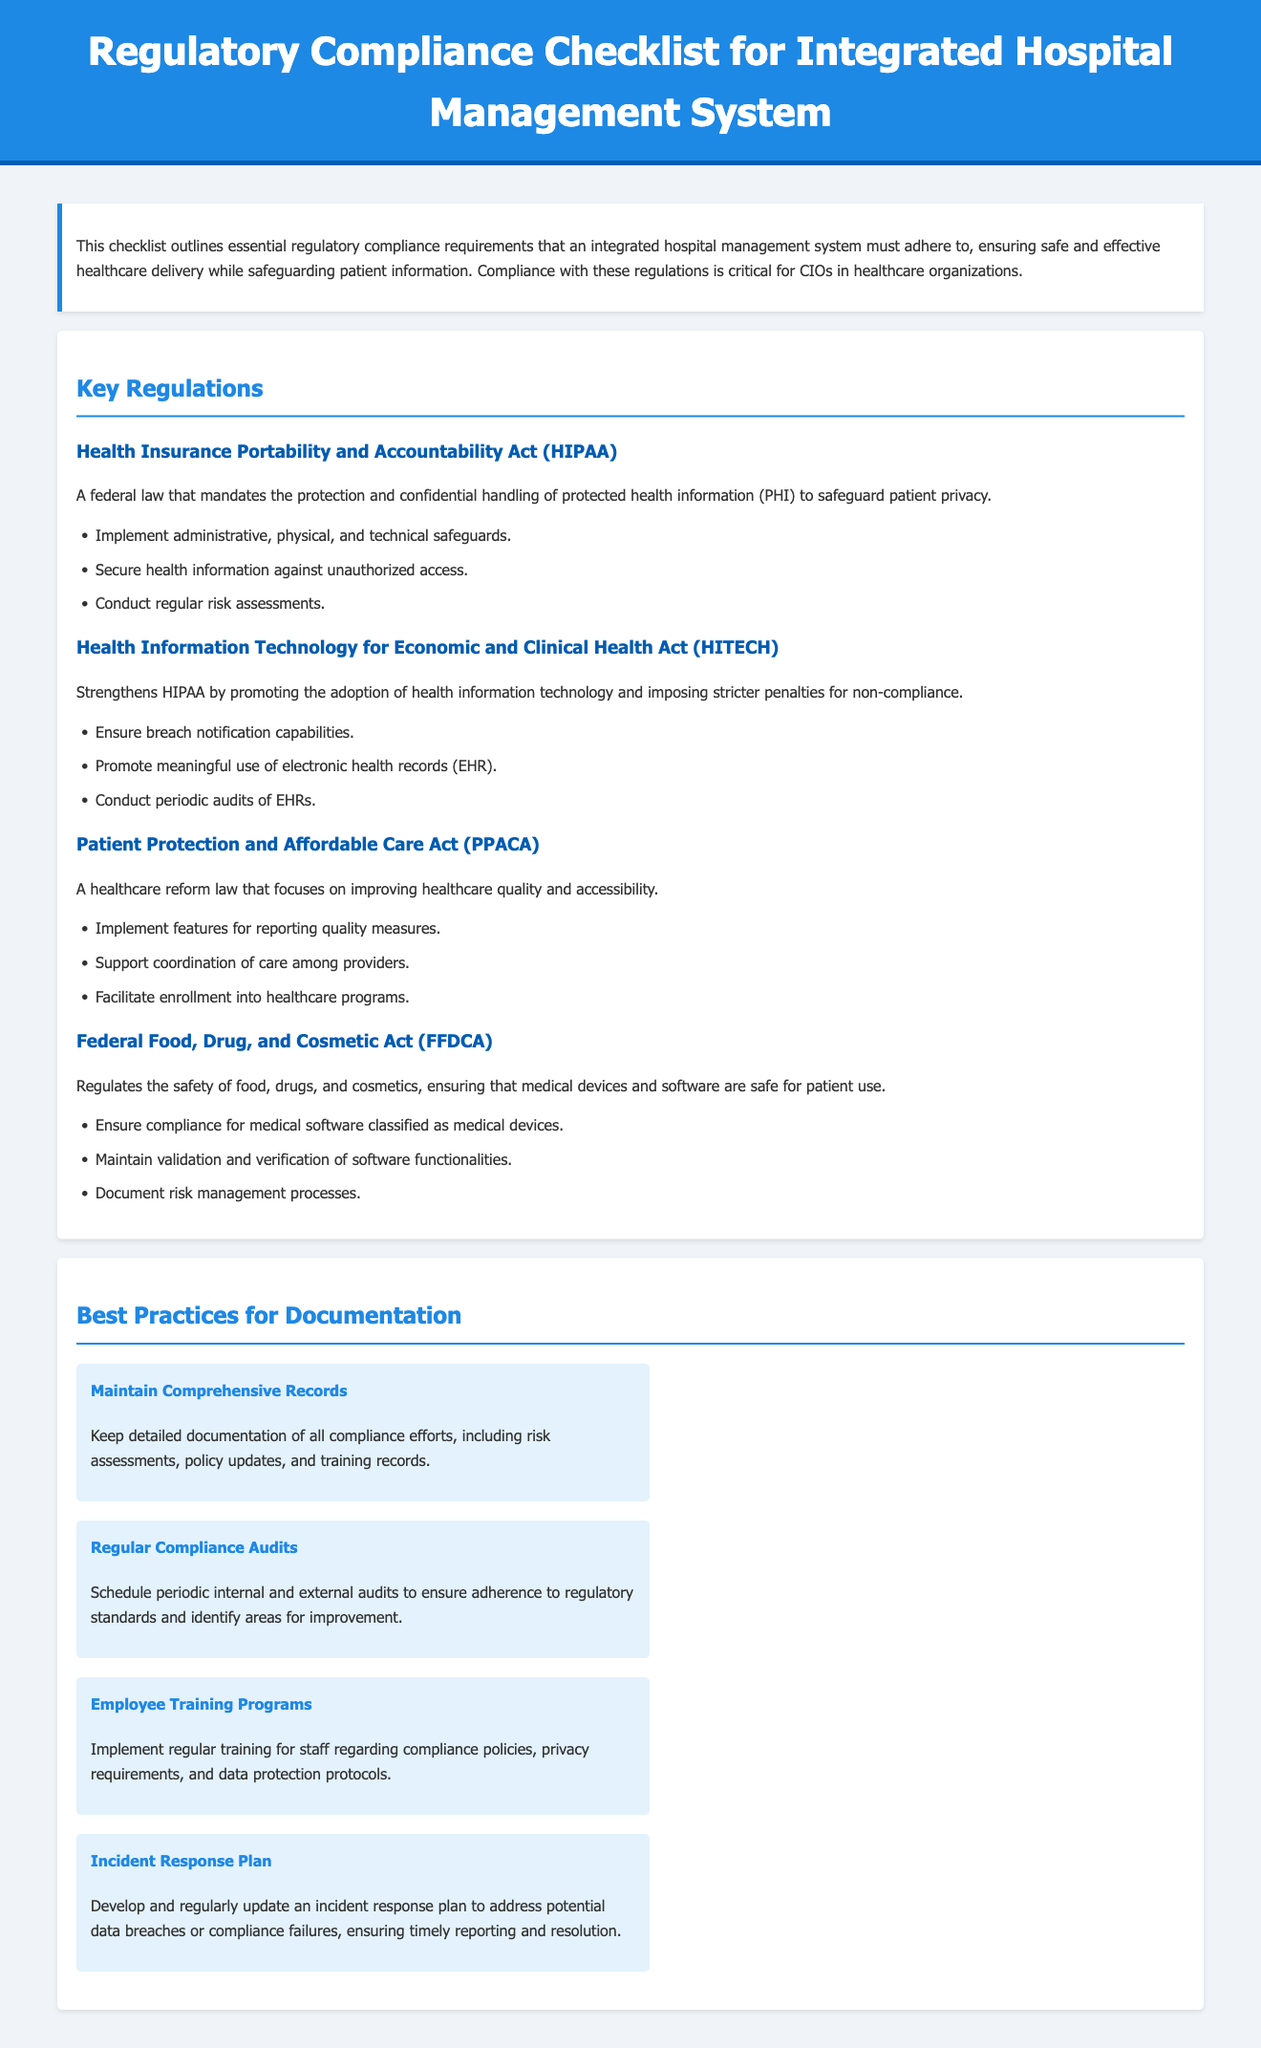What is the title of the document? The title of the document is stated in the header of the rendered document.
Answer: Regulatory Compliance Checklist for Integrated Hospital Management System What does HIPAA stand for? HIPAA is an abbreviation for the regulation mentioned in the document, which is defined in the Key Regulations section.
Answer: Health Insurance Portability and Accountability Act What is one requirement of HITECH? The document lists specific requirements under HITECH in the Key Regulations section.
Answer: Ensure breach notification capabilities How many best practices for documentation are listed? The number of practices can be found in the Best Practices for Documentation section of the document.
Answer: Four What does FFDCA regulate? The document provides information about what FFDCA regulates in the context of healthcare.
Answer: Safety of food, drugs, and cosmetics Name one best practice for documentation. The document includes specific practices in the Best Practices for Documentation section.
Answer: Maintain Comprehensive Records Which act strengthens HIPAA? The document specifies which act strengthens HIPAA in the Key Regulations section.
Answer: HITECH What is required to support coordination of care? The requirements for coordinating care are detailed in the PPACA section of the document.
Answer: Implement features for reporting quality measures 